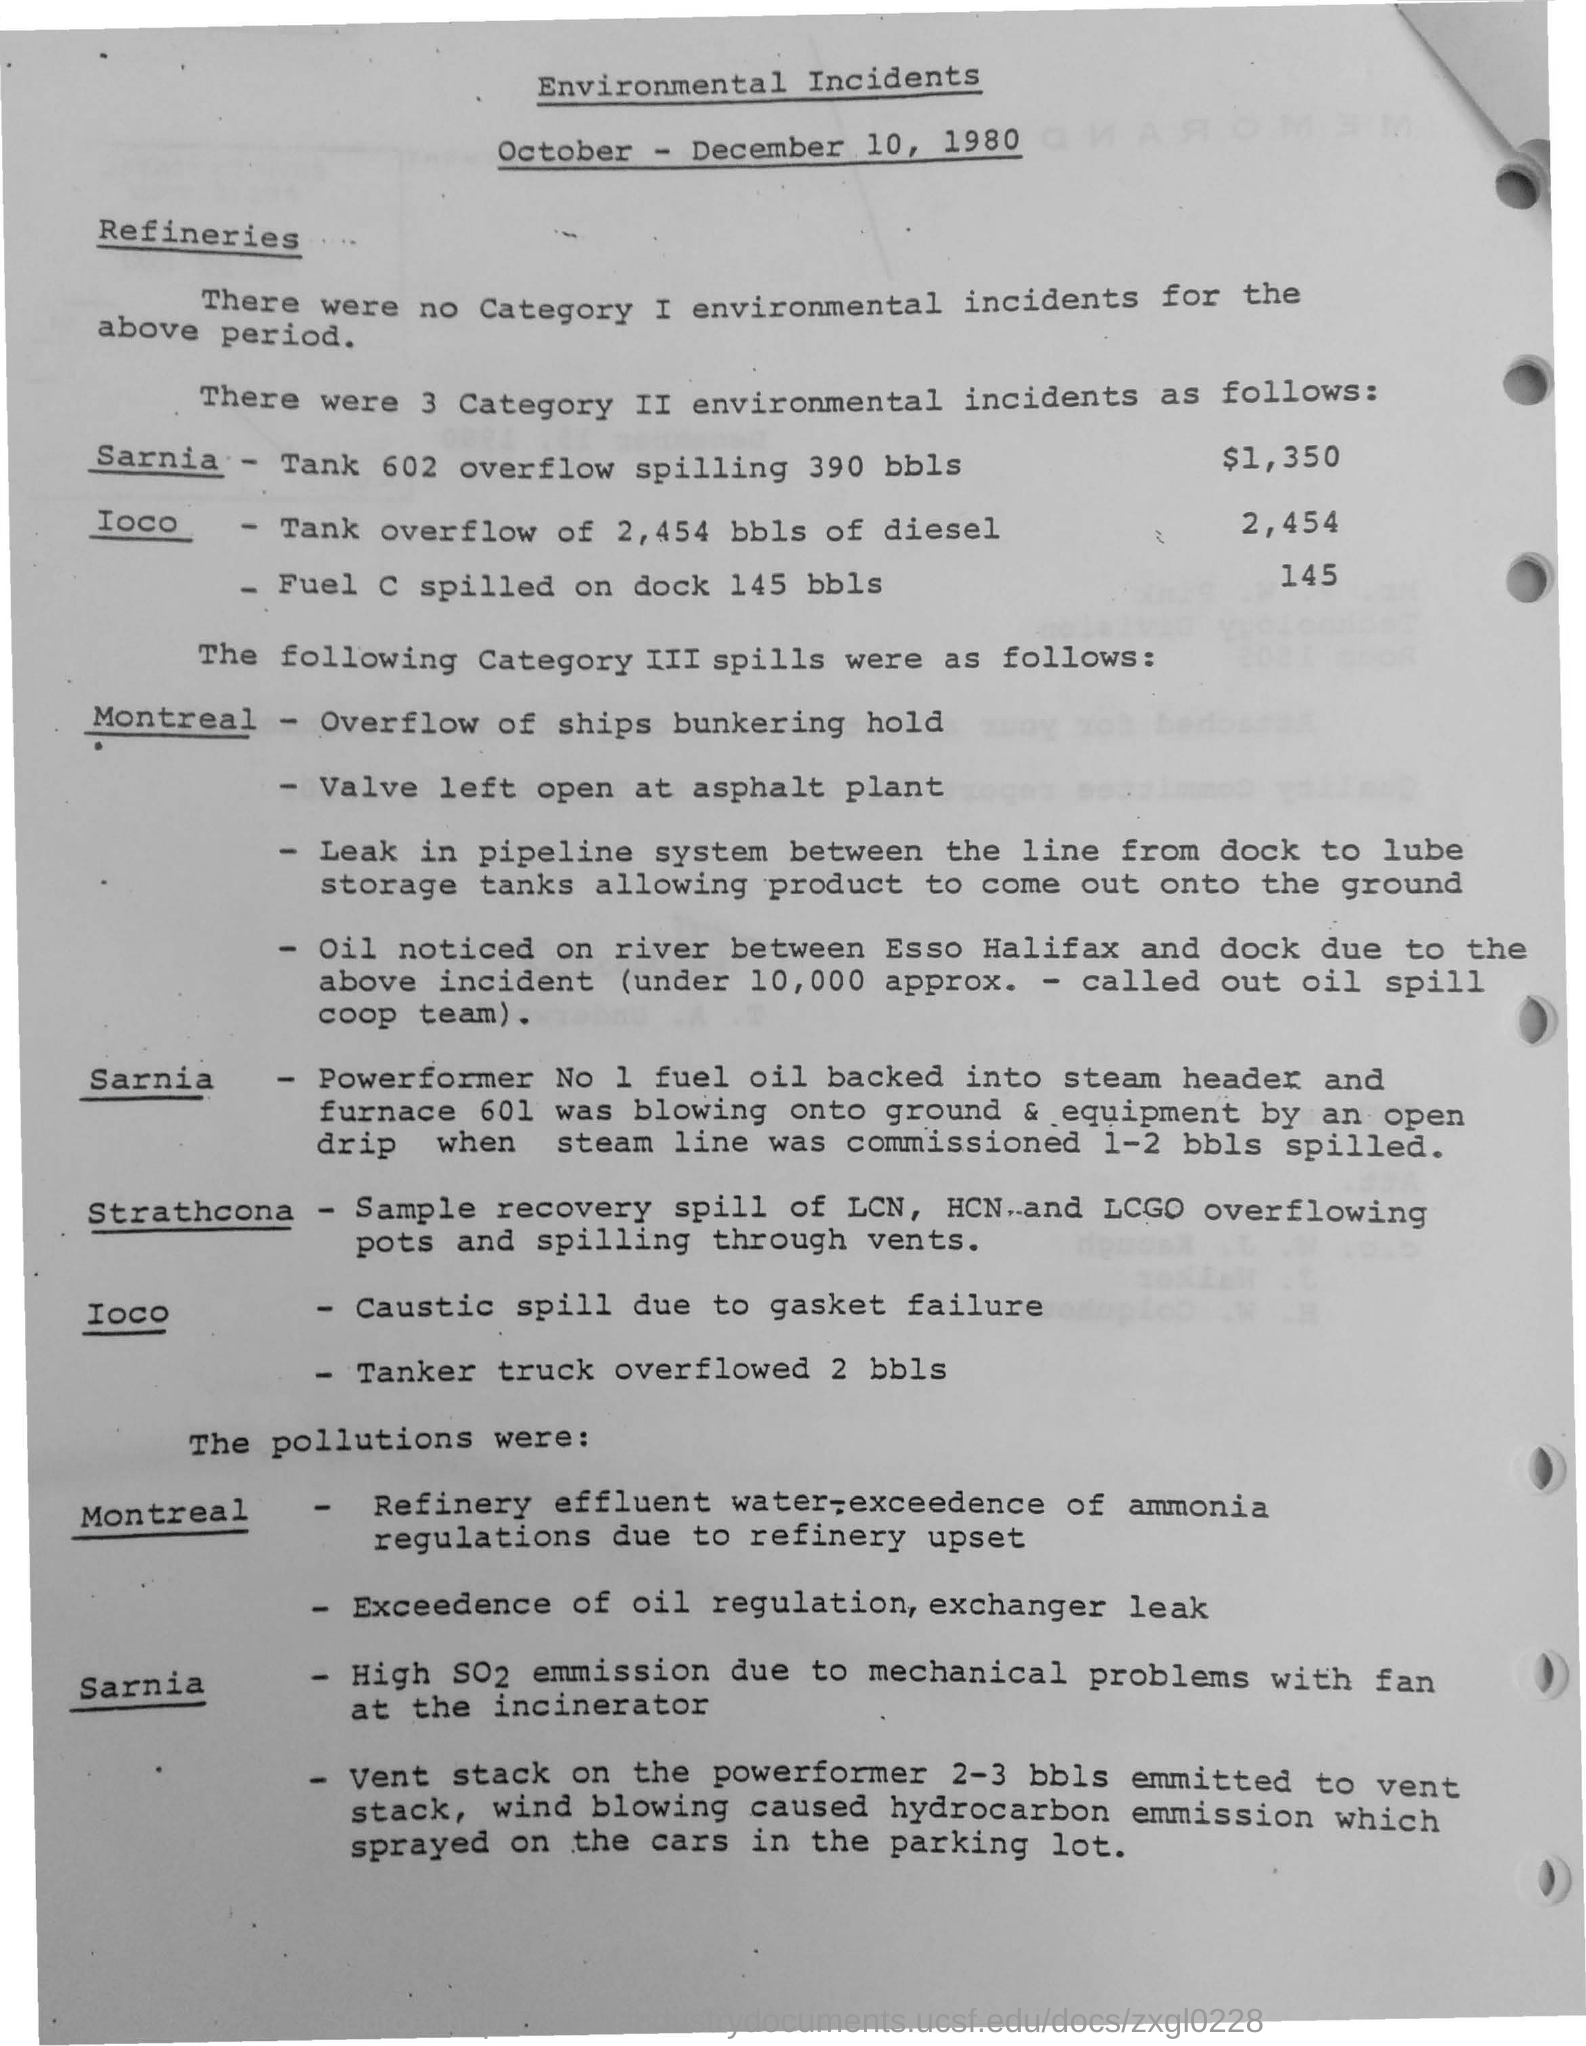The title mentions environmental incidents in which year?
Offer a terse response. 1980. Fuel c spilled on dock of how many bbls?
Keep it short and to the point. 145. Valve was left open at which plant?
Provide a succinct answer. Asphalt plant. High emission of which gas is mentioned due to mechanical problems with fan at the incinerator?
Offer a very short reply. SO2. 